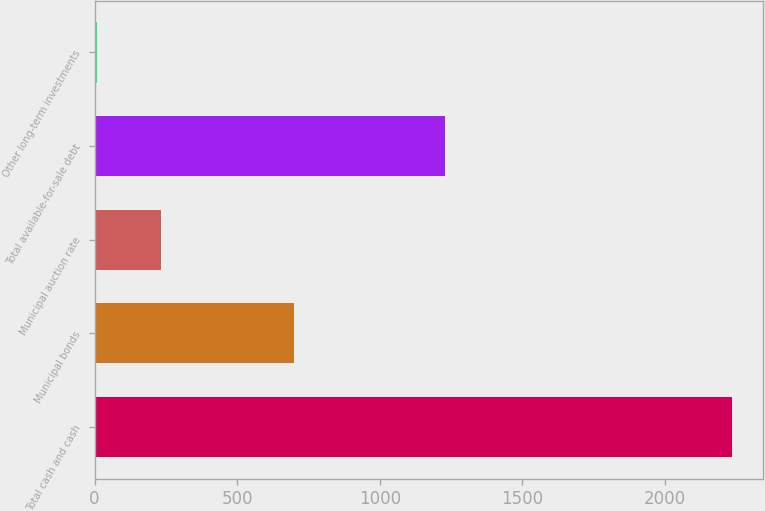Convert chart to OTSL. <chart><loc_0><loc_0><loc_500><loc_500><bar_chart><fcel>Total cash and cash<fcel>Municipal bonds<fcel>Municipal auction rate<fcel>Total available-for-sale debt<fcel>Other long-term investments<nl><fcel>2234<fcel>701<fcel>232.4<fcel>1230<fcel>10<nl></chart> 